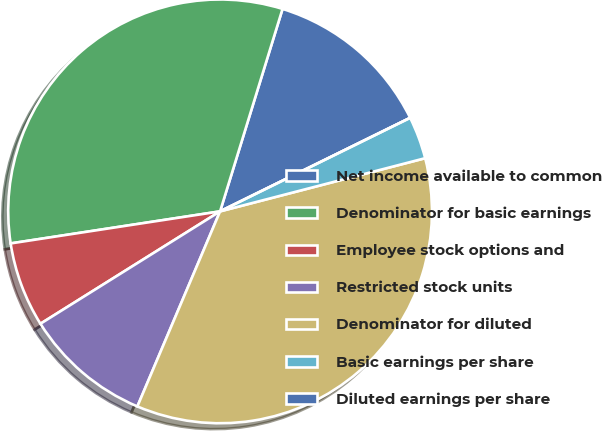<chart> <loc_0><loc_0><loc_500><loc_500><pie_chart><fcel>Net income available to common<fcel>Denominator for basic earnings<fcel>Employee stock options and<fcel>Restricted stock units<fcel>Denominator for diluted<fcel>Basic earnings per share<fcel>Diluted earnings per share<nl><fcel>12.96%<fcel>32.18%<fcel>6.48%<fcel>9.72%<fcel>35.42%<fcel>3.24%<fcel>0.0%<nl></chart> 